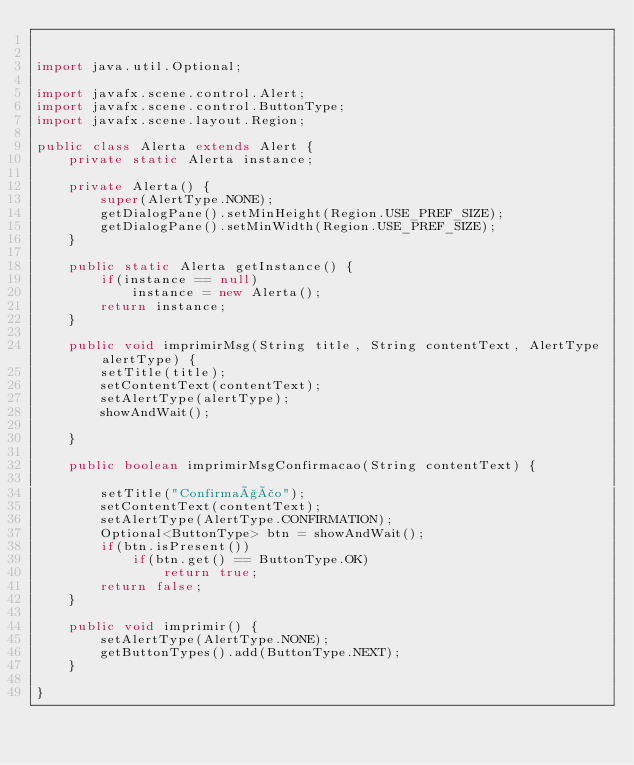Convert code to text. <code><loc_0><loc_0><loc_500><loc_500><_Java_>

import java.util.Optional;

import javafx.scene.control.Alert;
import javafx.scene.control.ButtonType;
import javafx.scene.layout.Region;

public class Alerta extends Alert {
	private static Alerta instance;
	
	private Alerta() {
		super(AlertType.NONE);
		getDialogPane().setMinHeight(Region.USE_PREF_SIZE);
		getDialogPane().setMinWidth(Region.USE_PREF_SIZE);
	}
	
	public static Alerta getInstance() {
		if(instance == null)
			instance = new Alerta();
		return instance;
	}
	
	public void imprimirMsg(String title, String contentText, AlertType alertType) {
		setTitle(title);
		setContentText(contentText);
		setAlertType(alertType);
		showAndWait();
		
	}
	
	public boolean imprimirMsgConfirmacao(String contentText) {
		
		setTitle("Confirmação");
		setContentText(contentText);
		setAlertType(AlertType.CONFIRMATION);
		Optional<ButtonType> btn = showAndWait();
		if(btn.isPresent())
			if(btn.get() == ButtonType.OK)
				return true;
		return false;
	}
	
	public void imprimir() {
		setAlertType(AlertType.NONE);
		getButtonTypes().add(ButtonType.NEXT);
	}
	
}
</code> 